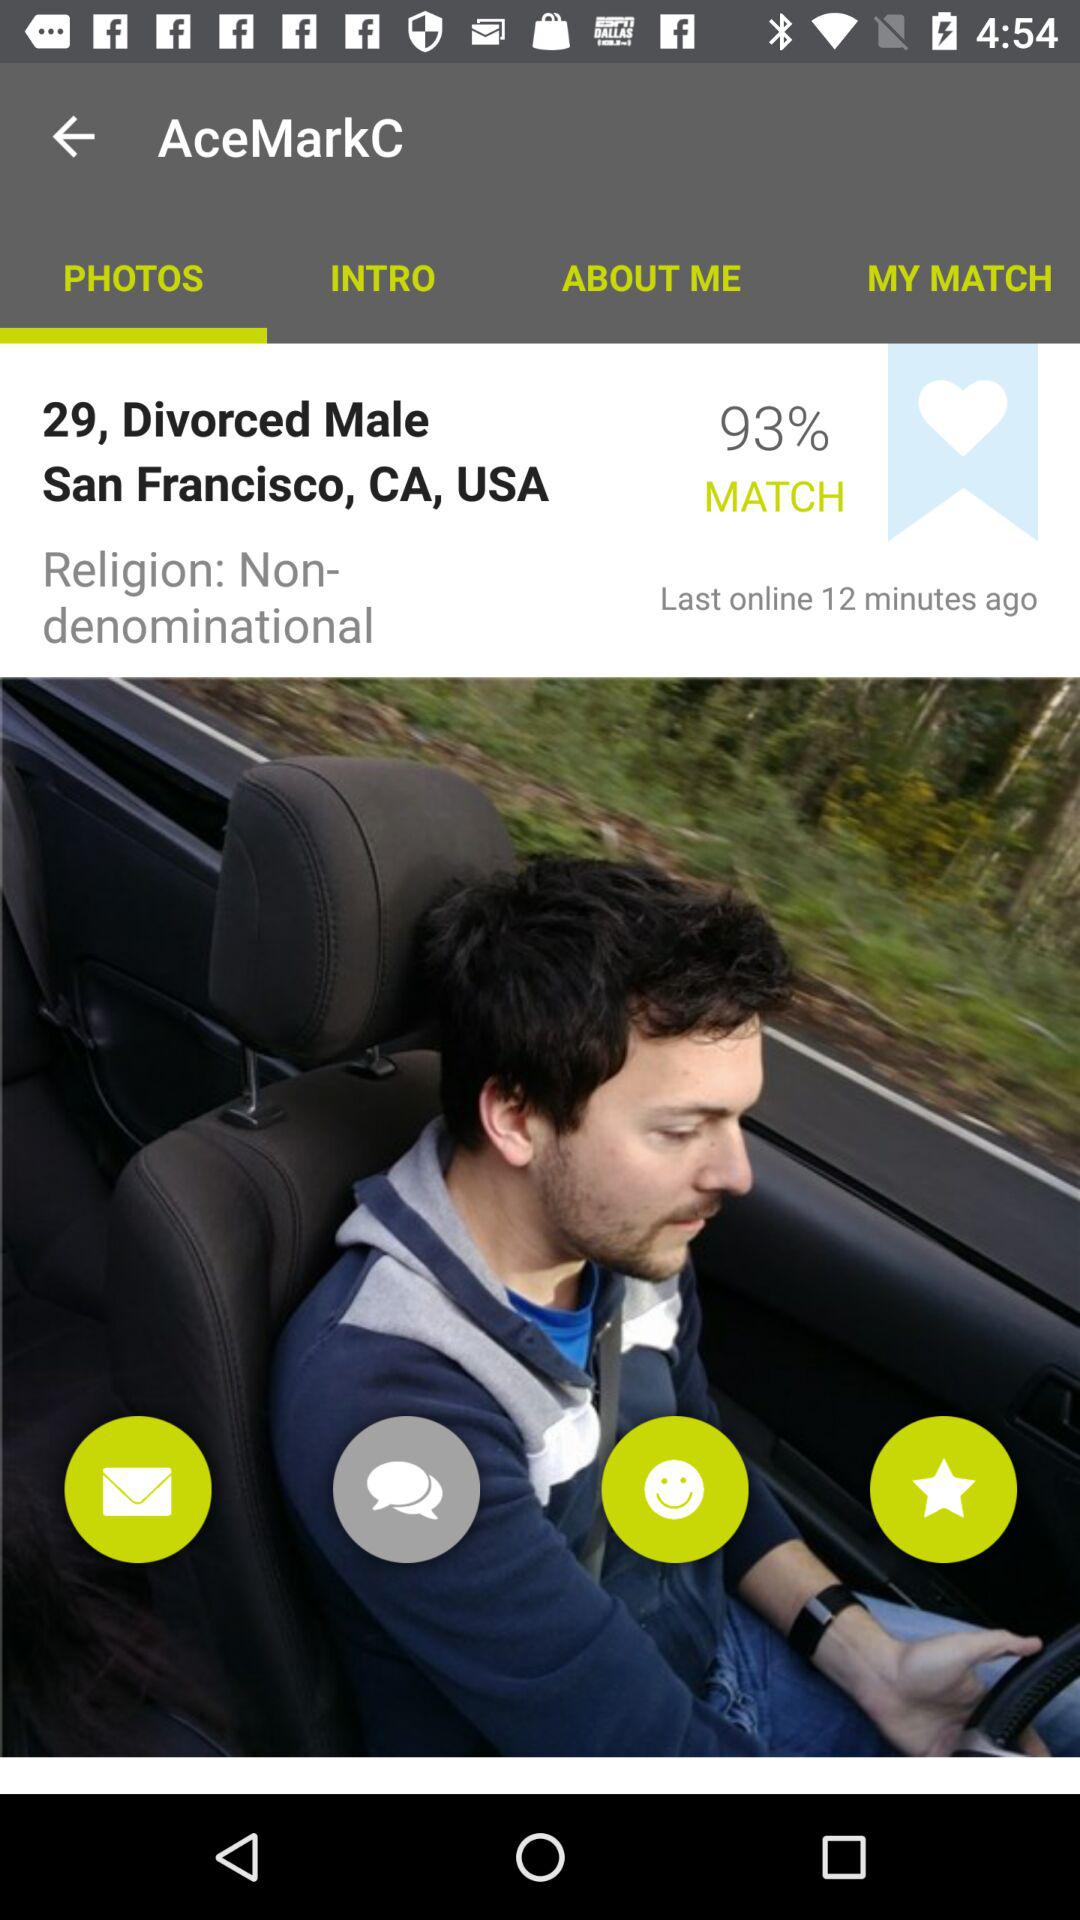What is the marital status? The marital status is Divorced. 